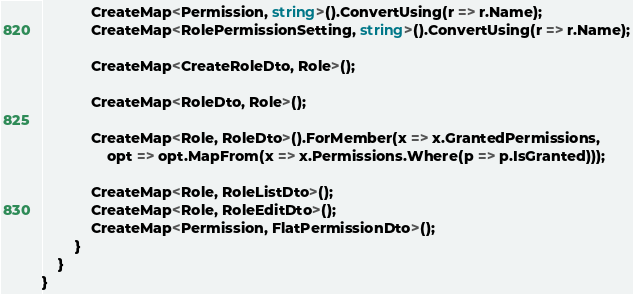Convert code to text. <code><loc_0><loc_0><loc_500><loc_500><_C#_>            CreateMap<Permission, string>().ConvertUsing(r => r.Name);
            CreateMap<RolePermissionSetting, string>().ConvertUsing(r => r.Name);

            CreateMap<CreateRoleDto, Role>();

            CreateMap<RoleDto, Role>();

            CreateMap<Role, RoleDto>().ForMember(x => x.GrantedPermissions,
                opt => opt.MapFrom(x => x.Permissions.Where(p => p.IsGranted)));

            CreateMap<Role, RoleListDto>();
            CreateMap<Role, RoleEditDto>();
            CreateMap<Permission, FlatPermissionDto>();
        }
    }
}
</code> 